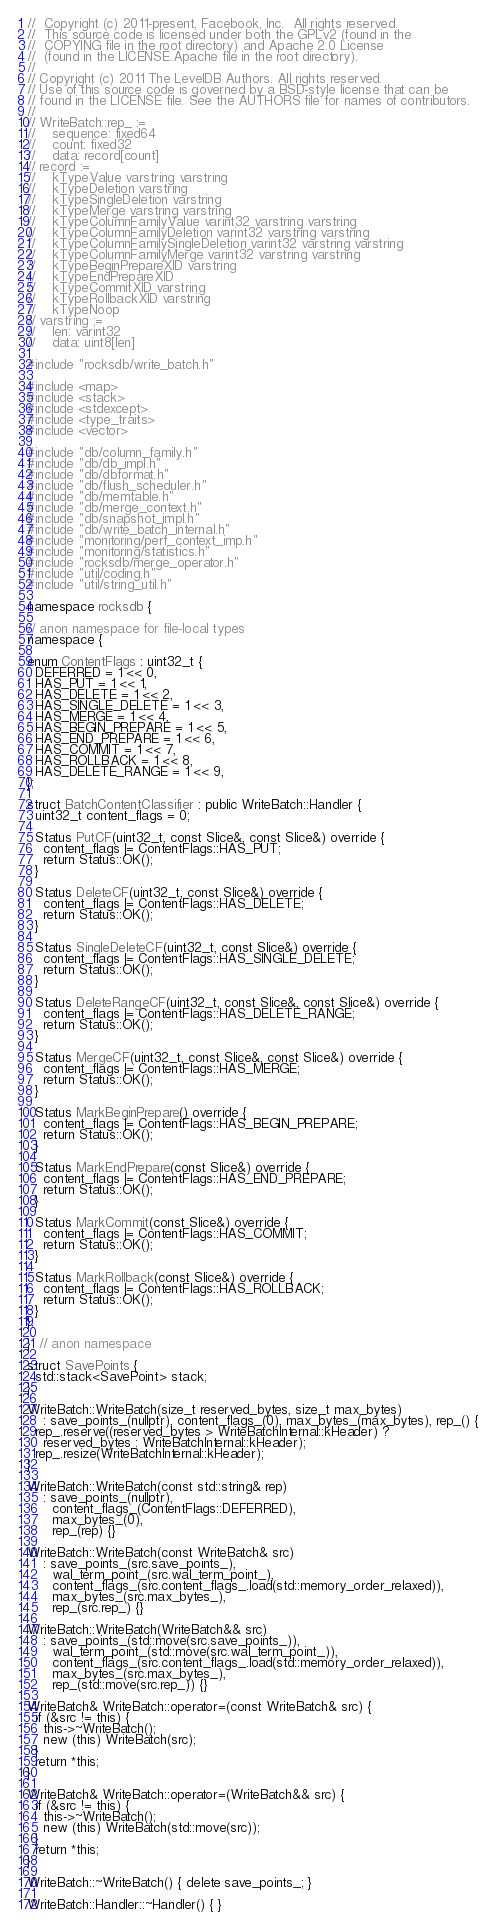Convert code to text. <code><loc_0><loc_0><loc_500><loc_500><_C++_>//  Copyright (c) 2011-present, Facebook, Inc.  All rights reserved.
//  This source code is licensed under both the GPLv2 (found in the
//  COPYING file in the root directory) and Apache 2.0 License
//  (found in the LICENSE.Apache file in the root directory).
//
// Copyright (c) 2011 The LevelDB Authors. All rights reserved.
// Use of this source code is governed by a BSD-style license that can be
// found in the LICENSE file. See the AUTHORS file for names of contributors.
//
// WriteBatch::rep_ :=
//    sequence: fixed64
//    count: fixed32
//    data: record[count]
// record :=
//    kTypeValue varstring varstring
//    kTypeDeletion varstring
//    kTypeSingleDeletion varstring
//    kTypeMerge varstring varstring
//    kTypeColumnFamilyValue varint32 varstring varstring
//    kTypeColumnFamilyDeletion varint32 varstring varstring
//    kTypeColumnFamilySingleDeletion varint32 varstring varstring
//    kTypeColumnFamilyMerge varint32 varstring varstring
//    kTypeBeginPrepareXID varstring
//    kTypeEndPrepareXID
//    kTypeCommitXID varstring
//    kTypeRollbackXID varstring
//    kTypeNoop
// varstring :=
//    len: varint32
//    data: uint8[len]

#include "rocksdb/write_batch.h"

#include <map>
#include <stack>
#include <stdexcept>
#include <type_traits>
#include <vector>

#include "db/column_family.h"
#include "db/db_impl.h"
#include "db/dbformat.h"
#include "db/flush_scheduler.h"
#include "db/memtable.h"
#include "db/merge_context.h"
#include "db/snapshot_impl.h"
#include "db/write_batch_internal.h"
#include "monitoring/perf_context_imp.h"
#include "monitoring/statistics.h"
#include "rocksdb/merge_operator.h"
#include "util/coding.h"
#include "util/string_util.h"

namespace rocksdb {

// anon namespace for file-local types
namespace {

enum ContentFlags : uint32_t {
  DEFERRED = 1 << 0,
  HAS_PUT = 1 << 1,
  HAS_DELETE = 1 << 2,
  HAS_SINGLE_DELETE = 1 << 3,
  HAS_MERGE = 1 << 4,
  HAS_BEGIN_PREPARE = 1 << 5,
  HAS_END_PREPARE = 1 << 6,
  HAS_COMMIT = 1 << 7,
  HAS_ROLLBACK = 1 << 8,
  HAS_DELETE_RANGE = 1 << 9,
};

struct BatchContentClassifier : public WriteBatch::Handler {
  uint32_t content_flags = 0;

  Status PutCF(uint32_t, const Slice&, const Slice&) override {
    content_flags |= ContentFlags::HAS_PUT;
    return Status::OK();
  }

  Status DeleteCF(uint32_t, const Slice&) override {
    content_flags |= ContentFlags::HAS_DELETE;
    return Status::OK();
  }

  Status SingleDeleteCF(uint32_t, const Slice&) override {
    content_flags |= ContentFlags::HAS_SINGLE_DELETE;
    return Status::OK();
  }

  Status DeleteRangeCF(uint32_t, const Slice&, const Slice&) override {
    content_flags |= ContentFlags::HAS_DELETE_RANGE;
    return Status::OK();
  }

  Status MergeCF(uint32_t, const Slice&, const Slice&) override {
    content_flags |= ContentFlags::HAS_MERGE;
    return Status::OK();
  }

  Status MarkBeginPrepare() override {
    content_flags |= ContentFlags::HAS_BEGIN_PREPARE;
    return Status::OK();
  }

  Status MarkEndPrepare(const Slice&) override {
    content_flags |= ContentFlags::HAS_END_PREPARE;
    return Status::OK();
  }

  Status MarkCommit(const Slice&) override {
    content_flags |= ContentFlags::HAS_COMMIT;
    return Status::OK();
  }

  Status MarkRollback(const Slice&) override {
    content_flags |= ContentFlags::HAS_ROLLBACK;
    return Status::OK();
  }
};

}  // anon namespace

struct SavePoints {
  std::stack<SavePoint> stack;
};

WriteBatch::WriteBatch(size_t reserved_bytes, size_t max_bytes)
    : save_points_(nullptr), content_flags_(0), max_bytes_(max_bytes), rep_() {
  rep_.reserve((reserved_bytes > WriteBatchInternal::kHeader) ?
    reserved_bytes : WriteBatchInternal::kHeader);
  rep_.resize(WriteBatchInternal::kHeader);
}

WriteBatch::WriteBatch(const std::string& rep)
    : save_points_(nullptr),
      content_flags_(ContentFlags::DEFERRED),
      max_bytes_(0),
      rep_(rep) {}

WriteBatch::WriteBatch(const WriteBatch& src)
    : save_points_(src.save_points_),
      wal_term_point_(src.wal_term_point_),
      content_flags_(src.content_flags_.load(std::memory_order_relaxed)),
      max_bytes_(src.max_bytes_),
      rep_(src.rep_) {}

WriteBatch::WriteBatch(WriteBatch&& src)
    : save_points_(std::move(src.save_points_)),
      wal_term_point_(std::move(src.wal_term_point_)),
      content_flags_(src.content_flags_.load(std::memory_order_relaxed)),
      max_bytes_(src.max_bytes_),
      rep_(std::move(src.rep_)) {}

WriteBatch& WriteBatch::operator=(const WriteBatch& src) {
  if (&src != this) {
    this->~WriteBatch();
    new (this) WriteBatch(src);
  }
  return *this;
}

WriteBatch& WriteBatch::operator=(WriteBatch&& src) {
  if (&src != this) {
    this->~WriteBatch();
    new (this) WriteBatch(std::move(src));
  }
  return *this;
}

WriteBatch::~WriteBatch() { delete save_points_; }

WriteBatch::Handler::~Handler() { }
</code> 